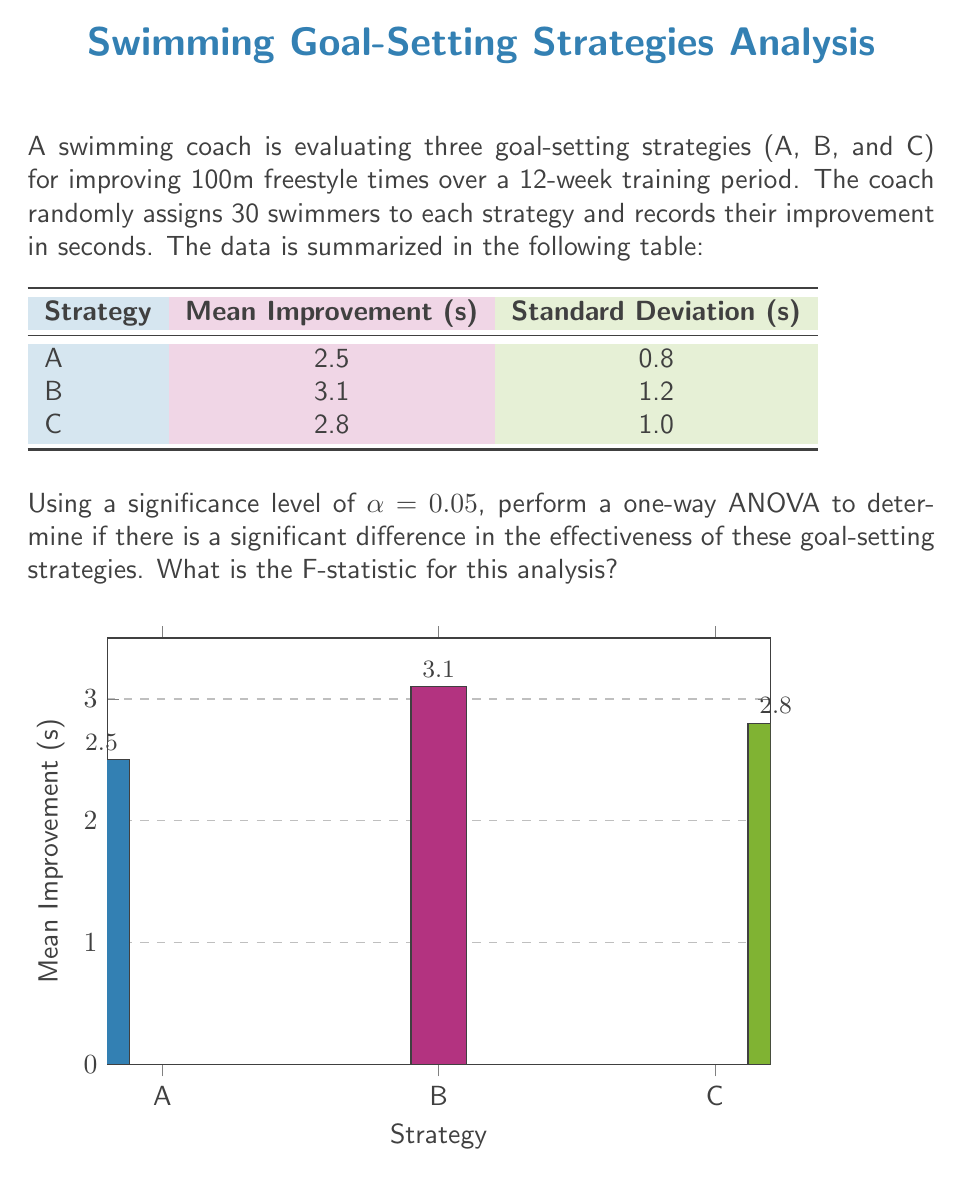Help me with this question. To perform a one-way ANOVA and calculate the F-statistic, we'll follow these steps:

1) Calculate the total sum of squares (SST):
   $$SST = \sum_{i=1}^{k} n_i((\bar{x}_i - \bar{x})^2)$$
   where k is the number of groups, $n_i$ is the number of observations in each group, $\bar{x}_i$ is the mean of each group, and $\bar{x}$ is the grand mean.

2) Calculate the between-group sum of squares (SSB):
   $$SSB = \sum_{i=1}^{k} n_i((\bar{x}_i - \bar{x})^2)$$

3) Calculate the within-group sum of squares (SSW):
   $$SSW = SST - SSB$$

4) Calculate the degrees of freedom:
   - Between groups: $df_B = k - 1 = 3 - 1 = 2$
   - Within groups: $df_W = N - k = 90 - 3 = 87$
   - Total: $df_T = N - 1 = 90 - 1 = 89$

5) Calculate the mean squares:
   $$MS_B = \frac{SSB}{df_B}$$
   $$MS_W = \frac{SSW}{df_W}$$

6) Calculate the F-statistic:
   $$F = \frac{MS_B}{MS_W}$$

Let's perform the calculations:

Grand mean: $\bar{x} = \frac{2.5 + 3.1 + 2.8}{3} = 2.8$

SSB = 30((2.5 - 2.8)^2 + (3.1 - 2.8)^2 + (2.8 - 2.8)^2)
    = 30(0.09 + 0.09 + 0)
    = 5.4

SST = 30((2.5 - 2.8)^2 + (3.1 - 2.8)^2 + (2.8 - 2.8)^2) + (29 * 0.8^2 + 29 * 1.2^2 + 29 * 1.0^2)
    = 5.4 + 18.56 + 41.76 + 29
    = 94.72

SSW = SST - SSB = 94.72 - 5.4 = 89.32

MS_B = SSB / df_B = 5.4 / 2 = 2.7
MS_W = SSW / df_W = 89.32 / 87 ≈ 1.0267

F = MS_B / MS_W = 2.7 / 1.0267 ≈ 2.63
Answer: 2.63 